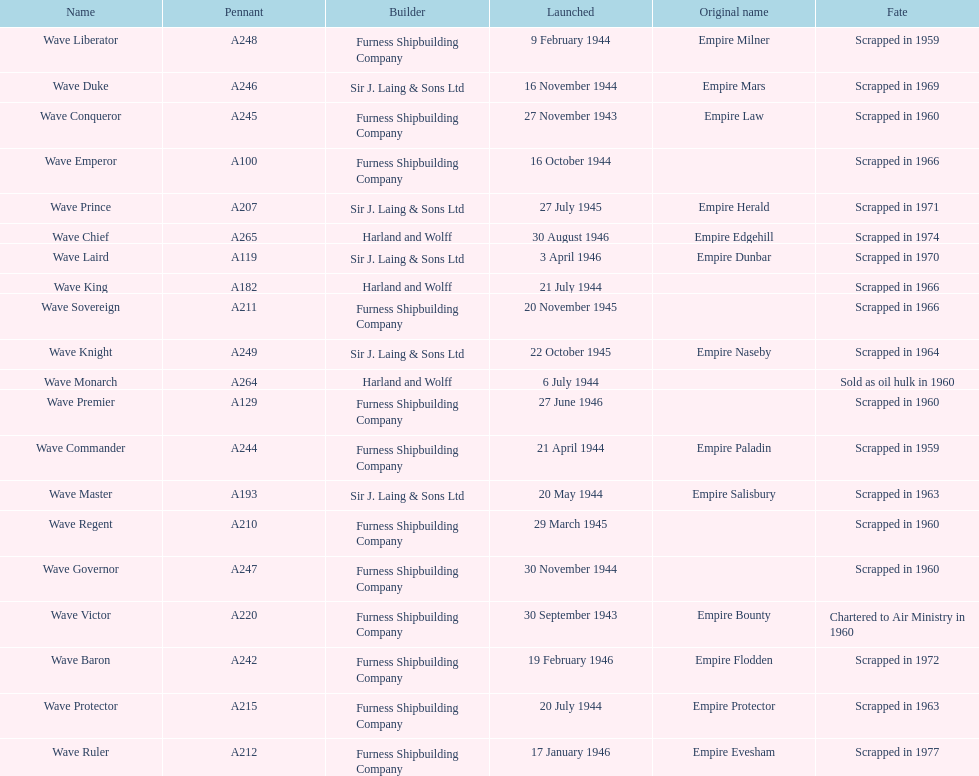Name a builder with "and" in the name. Harland and Wolff. 